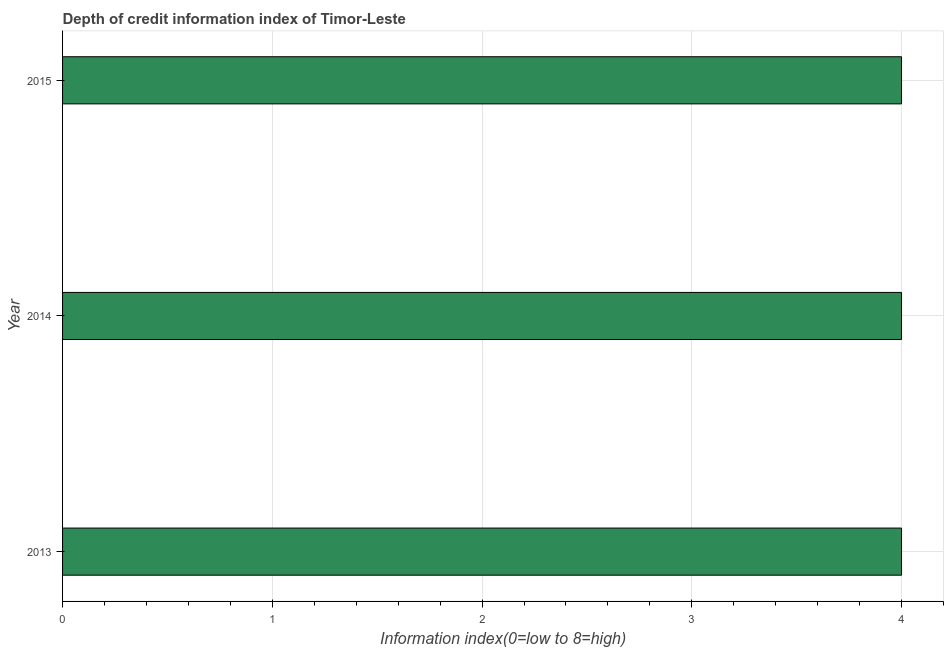Does the graph contain grids?
Keep it short and to the point. Yes. What is the title of the graph?
Keep it short and to the point. Depth of credit information index of Timor-Leste. What is the label or title of the X-axis?
Give a very brief answer. Information index(0=low to 8=high). What is the label or title of the Y-axis?
Your response must be concise. Year. In which year was the depth of credit information index minimum?
Your answer should be compact. 2013. What is the difference between the depth of credit information index in 2013 and 2014?
Offer a very short reply. 0. Is the difference between the depth of credit information index in 2013 and 2015 greater than the difference between any two years?
Give a very brief answer. Yes. How many bars are there?
Provide a short and direct response. 3. Are all the bars in the graph horizontal?
Give a very brief answer. Yes. What is the difference between two consecutive major ticks on the X-axis?
Your answer should be very brief. 1. Are the values on the major ticks of X-axis written in scientific E-notation?
Offer a terse response. No. What is the Information index(0=low to 8=high) of 2013?
Provide a short and direct response. 4. What is the Information index(0=low to 8=high) in 2014?
Your response must be concise. 4. What is the Information index(0=low to 8=high) in 2015?
Offer a very short reply. 4. What is the difference between the Information index(0=low to 8=high) in 2014 and 2015?
Your response must be concise. 0. What is the ratio of the Information index(0=low to 8=high) in 2014 to that in 2015?
Make the answer very short. 1. 